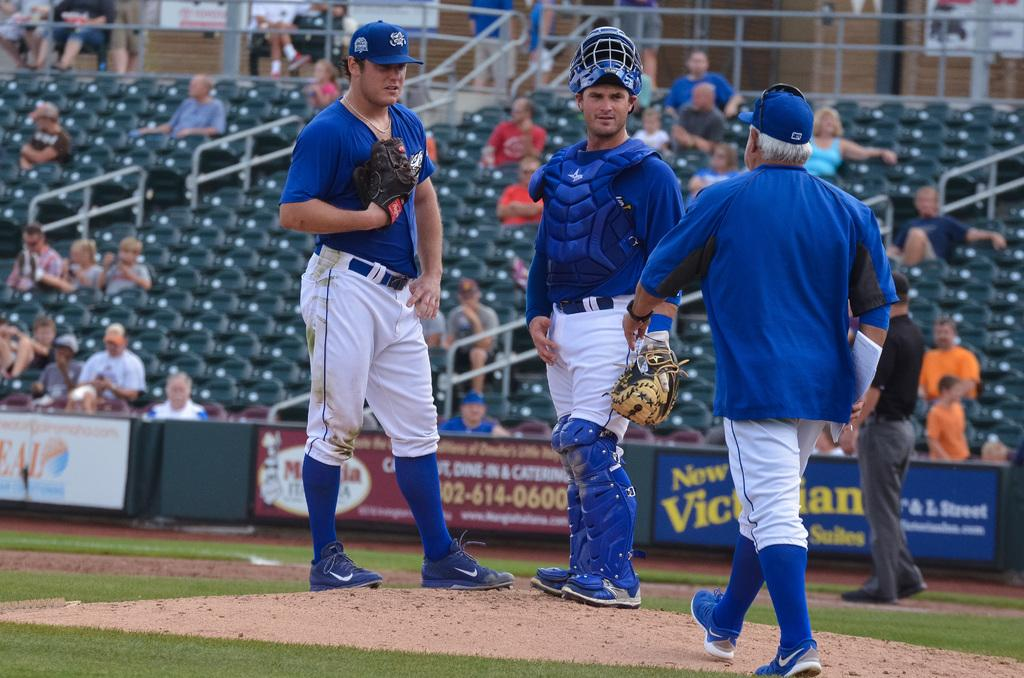<image>
Offer a succinct explanation of the picture presented. An ad for Dine in and Catering is on the wall behind the baseball players 